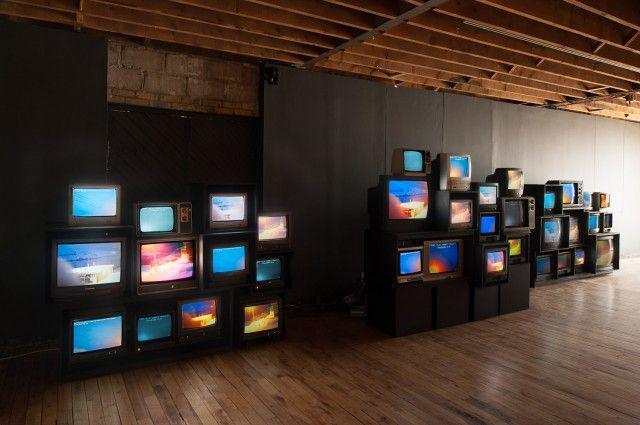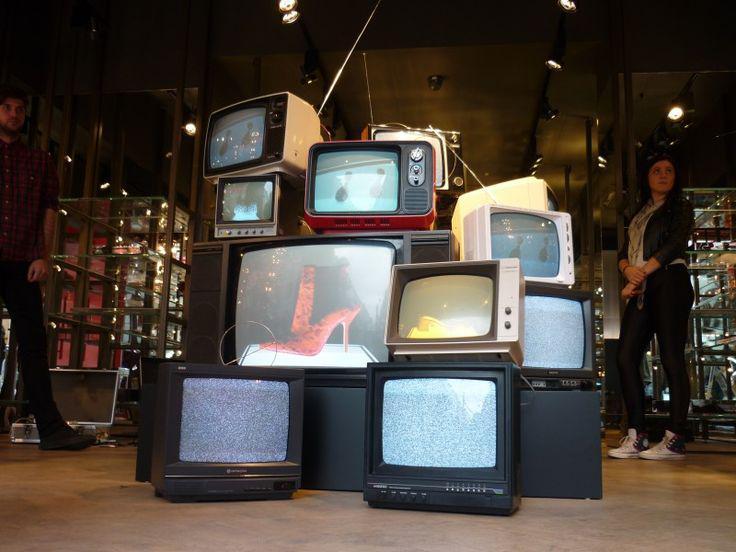The first image is the image on the left, the second image is the image on the right. For the images displayed, is the sentence "One image shows an interior with an exposed beam ceiling and multiple stacks of televisions with pictures on their screens stacked along the lefthand wall." factually correct? Answer yes or no. Yes. The first image is the image on the left, the second image is the image on the right. Assess this claim about the two images: "There are at least three televisions turned off.". Correct or not? Answer yes or no. No. 